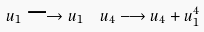<formula> <loc_0><loc_0><loc_500><loc_500>u _ { 1 } \longrightarrow u _ { 1 } & \quad u _ { 4 } \longrightarrow u _ { 4 } + u _ { 1 } ^ { 4 }</formula> 